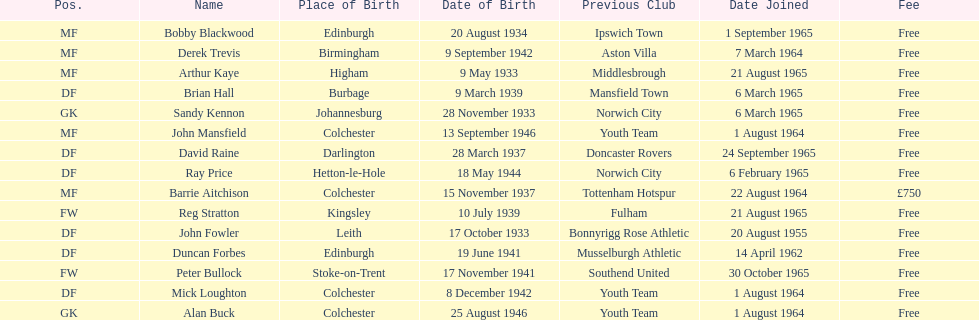What is the other fee listed, besides free? £750. 